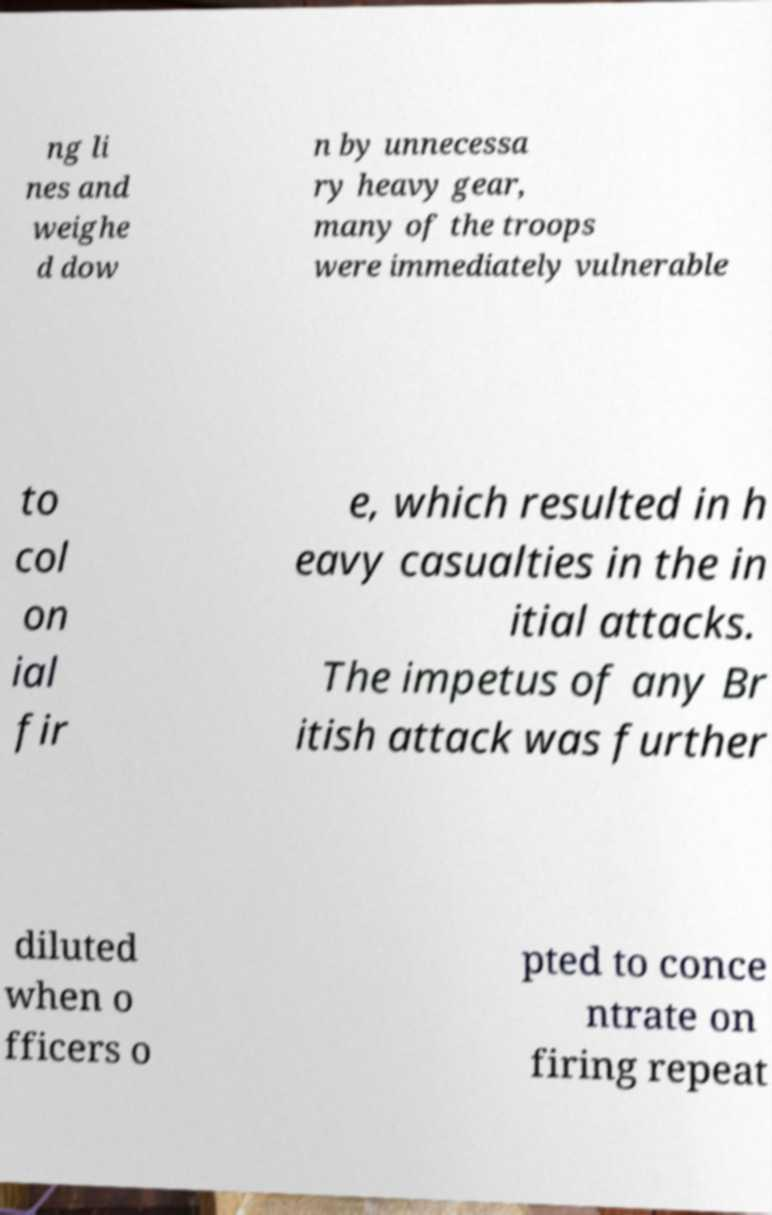Can you read and provide the text displayed in the image?This photo seems to have some interesting text. Can you extract and type it out for me? ng li nes and weighe d dow n by unnecessa ry heavy gear, many of the troops were immediately vulnerable to col on ial fir e, which resulted in h eavy casualties in the in itial attacks. The impetus of any Br itish attack was further diluted when o fficers o pted to conce ntrate on firing repeat 